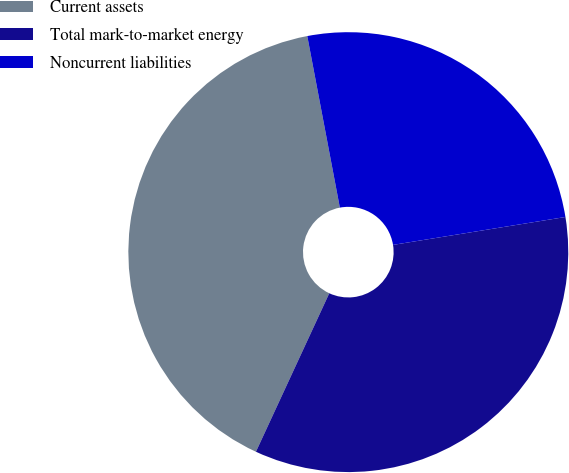<chart> <loc_0><loc_0><loc_500><loc_500><pie_chart><fcel>Current assets<fcel>Total mark-to-market energy<fcel>Noncurrent liabilities<nl><fcel>40.11%<fcel>34.45%<fcel>25.43%<nl></chart> 